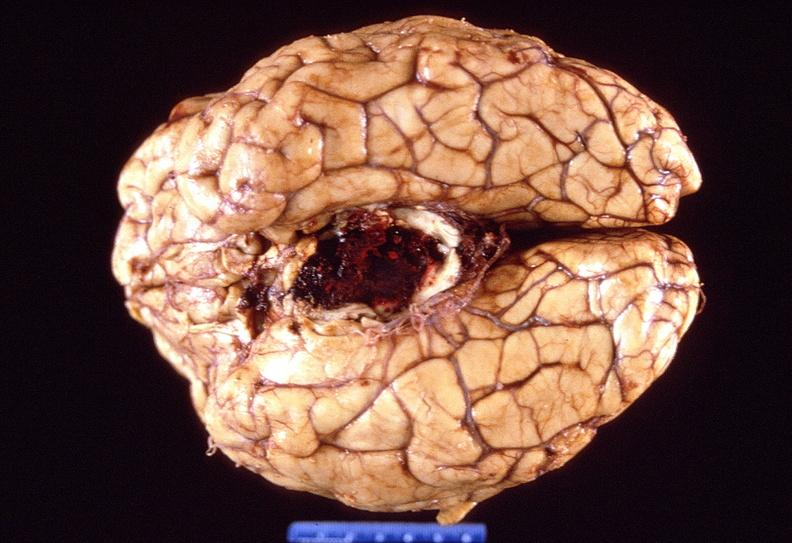what is present?
Answer the question using a single word or phrase. Nervous 